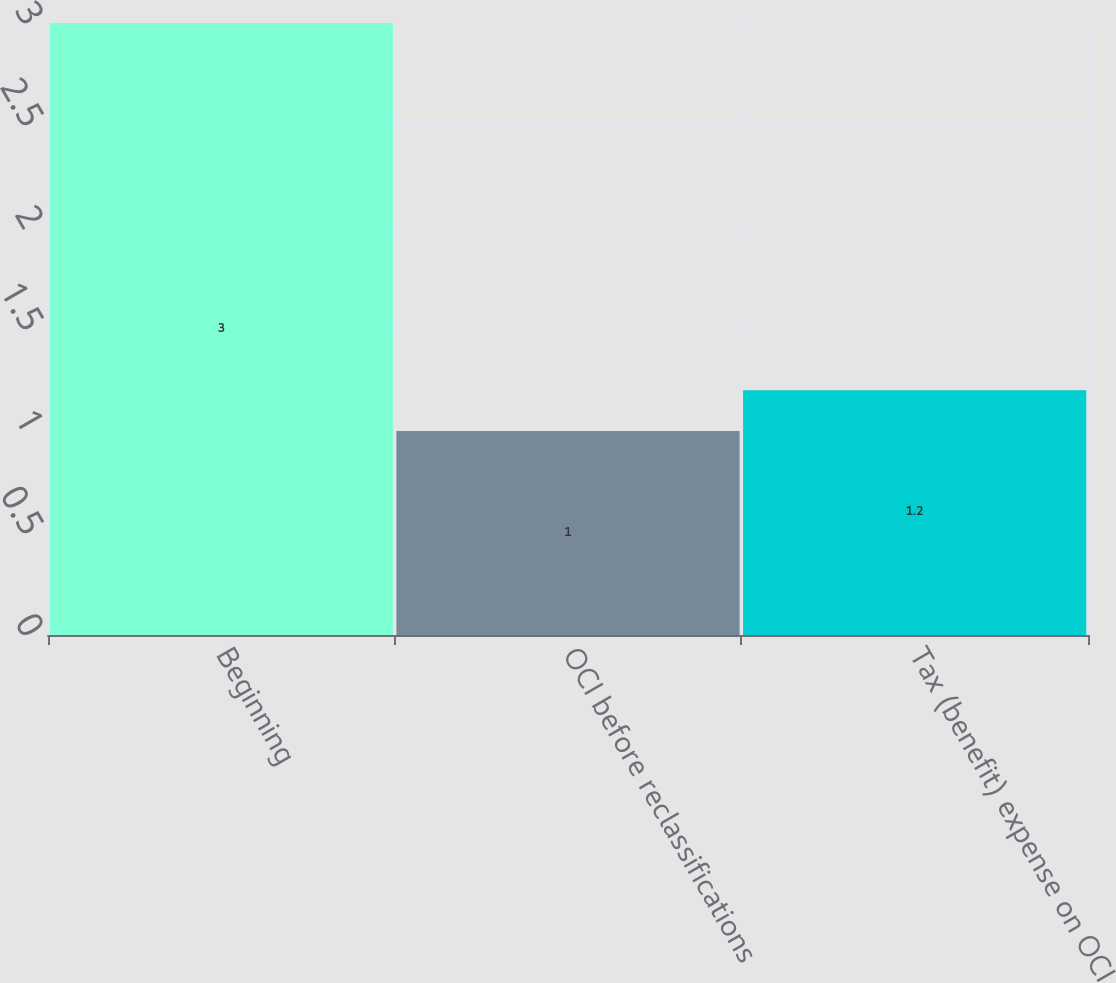Convert chart. <chart><loc_0><loc_0><loc_500><loc_500><bar_chart><fcel>Beginning<fcel>OCI before reclassifications<fcel>Tax (benefit) expense on OCI<nl><fcel>3<fcel>1<fcel>1.2<nl></chart> 